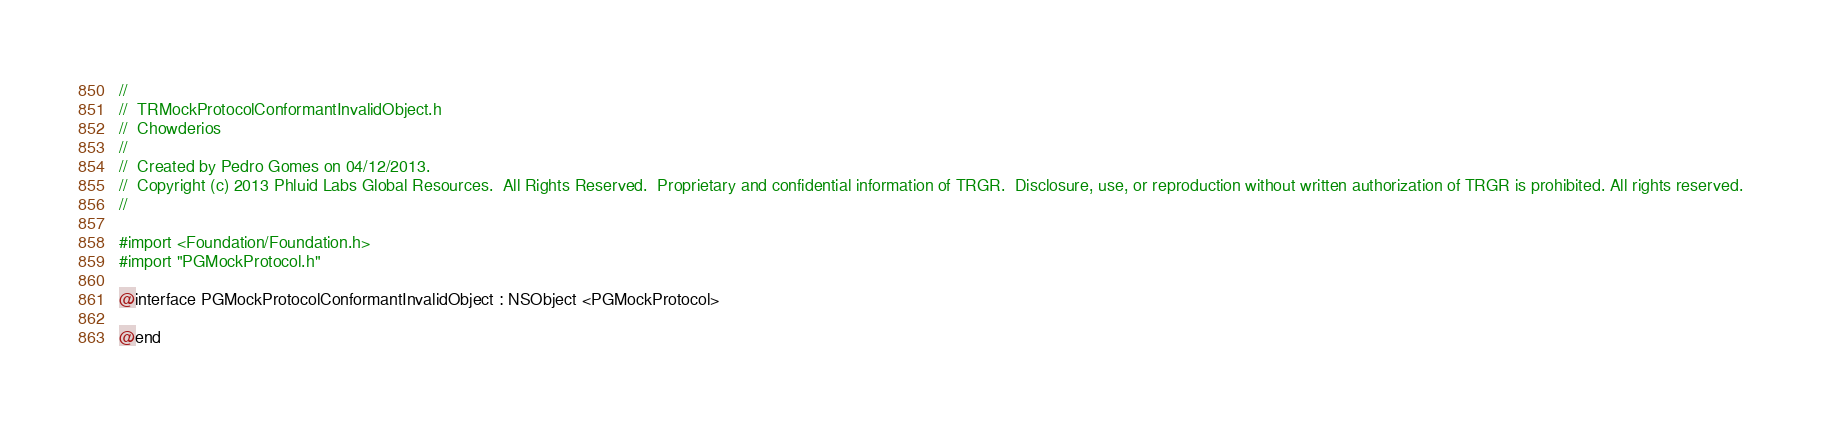Convert code to text. <code><loc_0><loc_0><loc_500><loc_500><_C_>//
//  TRMockProtocolConformantInvalidObject.h
//  Chowderios
//
//  Created by Pedro Gomes on 04/12/2013.
//  Copyright (c) 2013 Phluid Labs Global Resources.  All Rights Reserved.  Proprietary and confidential information of TRGR.  Disclosure, use, or reproduction without written authorization of TRGR is prohibited. All rights reserved.
//

#import <Foundation/Foundation.h>
#import "PGMockProtocol.h"

@interface PGMockProtocolConformantInvalidObject : NSObject <PGMockProtocol>

@end
</code> 